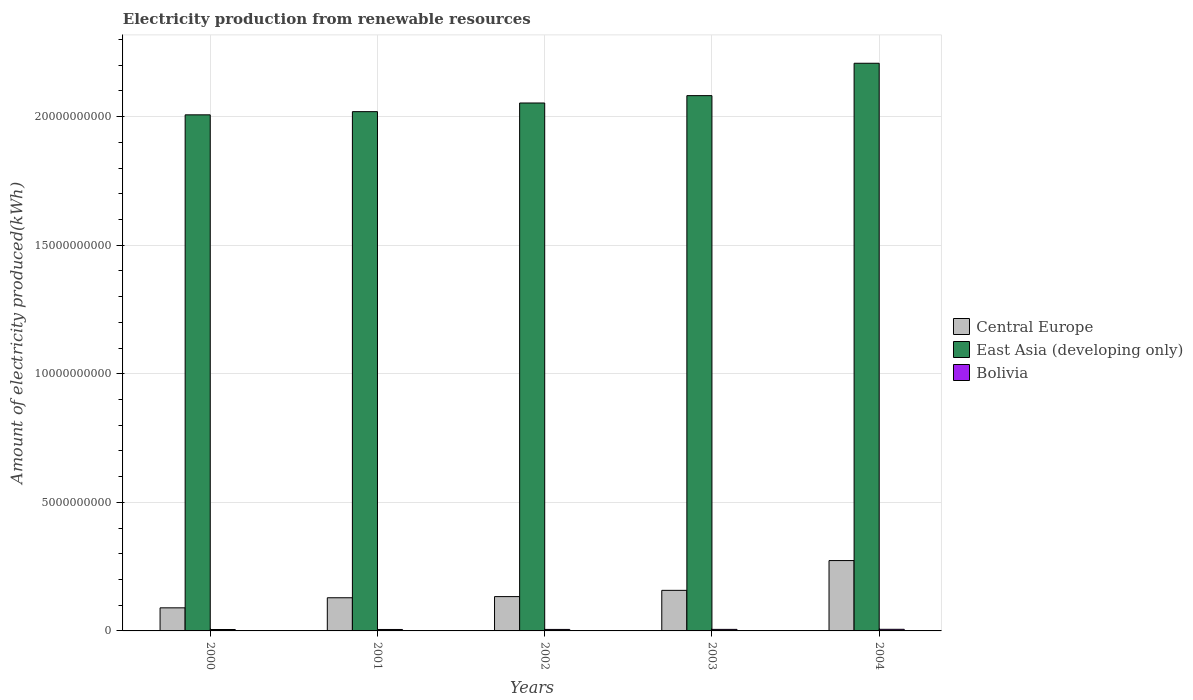What is the amount of electricity produced in Bolivia in 2003?
Make the answer very short. 6.00e+07. Across all years, what is the maximum amount of electricity produced in Bolivia?
Make the answer very short. 6.30e+07. Across all years, what is the minimum amount of electricity produced in Bolivia?
Ensure brevity in your answer.  5.50e+07. What is the total amount of electricity produced in Bolivia in the graph?
Provide a short and direct response. 2.92e+08. What is the difference between the amount of electricity produced in East Asia (developing only) in 2000 and that in 2004?
Offer a very short reply. -2.01e+09. What is the difference between the amount of electricity produced in Central Europe in 2003 and the amount of electricity produced in Bolivia in 2004?
Offer a very short reply. 1.52e+09. What is the average amount of electricity produced in Bolivia per year?
Give a very brief answer. 5.84e+07. In the year 2002, what is the difference between the amount of electricity produced in Central Europe and amount of electricity produced in East Asia (developing only)?
Offer a terse response. -1.92e+1. What is the ratio of the amount of electricity produced in East Asia (developing only) in 2000 to that in 2001?
Give a very brief answer. 0.99. Is the difference between the amount of electricity produced in Central Europe in 2000 and 2001 greater than the difference between the amount of electricity produced in East Asia (developing only) in 2000 and 2001?
Your answer should be very brief. No. What is the difference between the highest and the second highest amount of electricity produced in Bolivia?
Give a very brief answer. 3.00e+06. What is the difference between the highest and the lowest amount of electricity produced in East Asia (developing only)?
Keep it short and to the point. 2.01e+09. In how many years, is the amount of electricity produced in Bolivia greater than the average amount of electricity produced in Bolivia taken over all years?
Provide a succinct answer. 2. What does the 2nd bar from the right in 2003 represents?
Offer a very short reply. East Asia (developing only). Is it the case that in every year, the sum of the amount of electricity produced in Central Europe and amount of electricity produced in Bolivia is greater than the amount of electricity produced in East Asia (developing only)?
Ensure brevity in your answer.  No. Are the values on the major ticks of Y-axis written in scientific E-notation?
Offer a terse response. No. Does the graph contain grids?
Ensure brevity in your answer.  Yes. Where does the legend appear in the graph?
Offer a terse response. Center right. How many legend labels are there?
Your answer should be very brief. 3. How are the legend labels stacked?
Your response must be concise. Vertical. What is the title of the graph?
Your response must be concise. Electricity production from renewable resources. Does "India" appear as one of the legend labels in the graph?
Offer a terse response. No. What is the label or title of the X-axis?
Make the answer very short. Years. What is the label or title of the Y-axis?
Provide a succinct answer. Amount of electricity produced(kWh). What is the Amount of electricity produced(kWh) in Central Europe in 2000?
Your answer should be very brief. 8.98e+08. What is the Amount of electricity produced(kWh) of East Asia (developing only) in 2000?
Your response must be concise. 2.01e+1. What is the Amount of electricity produced(kWh) of Bolivia in 2000?
Make the answer very short. 5.50e+07. What is the Amount of electricity produced(kWh) in Central Europe in 2001?
Your answer should be very brief. 1.29e+09. What is the Amount of electricity produced(kWh) in East Asia (developing only) in 2001?
Make the answer very short. 2.02e+1. What is the Amount of electricity produced(kWh) in Bolivia in 2001?
Your answer should be compact. 5.60e+07. What is the Amount of electricity produced(kWh) of Central Europe in 2002?
Provide a succinct answer. 1.34e+09. What is the Amount of electricity produced(kWh) of East Asia (developing only) in 2002?
Offer a terse response. 2.05e+1. What is the Amount of electricity produced(kWh) of Bolivia in 2002?
Offer a terse response. 5.80e+07. What is the Amount of electricity produced(kWh) of Central Europe in 2003?
Your response must be concise. 1.58e+09. What is the Amount of electricity produced(kWh) of East Asia (developing only) in 2003?
Provide a succinct answer. 2.08e+1. What is the Amount of electricity produced(kWh) in Bolivia in 2003?
Offer a very short reply. 6.00e+07. What is the Amount of electricity produced(kWh) in Central Europe in 2004?
Offer a terse response. 2.74e+09. What is the Amount of electricity produced(kWh) in East Asia (developing only) in 2004?
Make the answer very short. 2.21e+1. What is the Amount of electricity produced(kWh) of Bolivia in 2004?
Offer a very short reply. 6.30e+07. Across all years, what is the maximum Amount of electricity produced(kWh) of Central Europe?
Your response must be concise. 2.74e+09. Across all years, what is the maximum Amount of electricity produced(kWh) in East Asia (developing only)?
Keep it short and to the point. 2.21e+1. Across all years, what is the maximum Amount of electricity produced(kWh) of Bolivia?
Ensure brevity in your answer.  6.30e+07. Across all years, what is the minimum Amount of electricity produced(kWh) of Central Europe?
Keep it short and to the point. 8.98e+08. Across all years, what is the minimum Amount of electricity produced(kWh) of East Asia (developing only)?
Your answer should be compact. 2.01e+1. Across all years, what is the minimum Amount of electricity produced(kWh) of Bolivia?
Provide a short and direct response. 5.50e+07. What is the total Amount of electricity produced(kWh) in Central Europe in the graph?
Offer a very short reply. 7.84e+09. What is the total Amount of electricity produced(kWh) of East Asia (developing only) in the graph?
Your response must be concise. 1.04e+11. What is the total Amount of electricity produced(kWh) in Bolivia in the graph?
Offer a very short reply. 2.92e+08. What is the difference between the Amount of electricity produced(kWh) in Central Europe in 2000 and that in 2001?
Ensure brevity in your answer.  -3.92e+08. What is the difference between the Amount of electricity produced(kWh) in East Asia (developing only) in 2000 and that in 2001?
Your response must be concise. -1.24e+08. What is the difference between the Amount of electricity produced(kWh) of Bolivia in 2000 and that in 2001?
Provide a short and direct response. -1.00e+06. What is the difference between the Amount of electricity produced(kWh) in Central Europe in 2000 and that in 2002?
Provide a succinct answer. -4.37e+08. What is the difference between the Amount of electricity produced(kWh) in East Asia (developing only) in 2000 and that in 2002?
Offer a very short reply. -4.61e+08. What is the difference between the Amount of electricity produced(kWh) in Central Europe in 2000 and that in 2003?
Your answer should be compact. -6.80e+08. What is the difference between the Amount of electricity produced(kWh) of East Asia (developing only) in 2000 and that in 2003?
Provide a short and direct response. -7.47e+08. What is the difference between the Amount of electricity produced(kWh) in Bolivia in 2000 and that in 2003?
Your response must be concise. -5.00e+06. What is the difference between the Amount of electricity produced(kWh) in Central Europe in 2000 and that in 2004?
Make the answer very short. -1.84e+09. What is the difference between the Amount of electricity produced(kWh) in East Asia (developing only) in 2000 and that in 2004?
Offer a terse response. -2.01e+09. What is the difference between the Amount of electricity produced(kWh) in Bolivia in 2000 and that in 2004?
Make the answer very short. -8.00e+06. What is the difference between the Amount of electricity produced(kWh) of Central Europe in 2001 and that in 2002?
Offer a very short reply. -4.50e+07. What is the difference between the Amount of electricity produced(kWh) of East Asia (developing only) in 2001 and that in 2002?
Provide a short and direct response. -3.37e+08. What is the difference between the Amount of electricity produced(kWh) in Bolivia in 2001 and that in 2002?
Your answer should be compact. -2.00e+06. What is the difference between the Amount of electricity produced(kWh) of Central Europe in 2001 and that in 2003?
Your answer should be compact. -2.88e+08. What is the difference between the Amount of electricity produced(kWh) in East Asia (developing only) in 2001 and that in 2003?
Offer a very short reply. -6.23e+08. What is the difference between the Amount of electricity produced(kWh) of Bolivia in 2001 and that in 2003?
Your answer should be very brief. -4.00e+06. What is the difference between the Amount of electricity produced(kWh) of Central Europe in 2001 and that in 2004?
Ensure brevity in your answer.  -1.45e+09. What is the difference between the Amount of electricity produced(kWh) in East Asia (developing only) in 2001 and that in 2004?
Your answer should be compact. -1.88e+09. What is the difference between the Amount of electricity produced(kWh) of Bolivia in 2001 and that in 2004?
Your answer should be very brief. -7.00e+06. What is the difference between the Amount of electricity produced(kWh) of Central Europe in 2002 and that in 2003?
Provide a short and direct response. -2.43e+08. What is the difference between the Amount of electricity produced(kWh) of East Asia (developing only) in 2002 and that in 2003?
Offer a terse response. -2.86e+08. What is the difference between the Amount of electricity produced(kWh) of Central Europe in 2002 and that in 2004?
Offer a very short reply. -1.40e+09. What is the difference between the Amount of electricity produced(kWh) of East Asia (developing only) in 2002 and that in 2004?
Offer a terse response. -1.54e+09. What is the difference between the Amount of electricity produced(kWh) of Bolivia in 2002 and that in 2004?
Offer a very short reply. -5.00e+06. What is the difference between the Amount of electricity produced(kWh) in Central Europe in 2003 and that in 2004?
Your answer should be very brief. -1.16e+09. What is the difference between the Amount of electricity produced(kWh) in East Asia (developing only) in 2003 and that in 2004?
Your answer should be very brief. -1.26e+09. What is the difference between the Amount of electricity produced(kWh) of Central Europe in 2000 and the Amount of electricity produced(kWh) of East Asia (developing only) in 2001?
Give a very brief answer. -1.93e+1. What is the difference between the Amount of electricity produced(kWh) in Central Europe in 2000 and the Amount of electricity produced(kWh) in Bolivia in 2001?
Your answer should be compact. 8.42e+08. What is the difference between the Amount of electricity produced(kWh) of East Asia (developing only) in 2000 and the Amount of electricity produced(kWh) of Bolivia in 2001?
Your response must be concise. 2.00e+1. What is the difference between the Amount of electricity produced(kWh) of Central Europe in 2000 and the Amount of electricity produced(kWh) of East Asia (developing only) in 2002?
Your answer should be compact. -1.96e+1. What is the difference between the Amount of electricity produced(kWh) of Central Europe in 2000 and the Amount of electricity produced(kWh) of Bolivia in 2002?
Ensure brevity in your answer.  8.40e+08. What is the difference between the Amount of electricity produced(kWh) in East Asia (developing only) in 2000 and the Amount of electricity produced(kWh) in Bolivia in 2002?
Provide a succinct answer. 2.00e+1. What is the difference between the Amount of electricity produced(kWh) of Central Europe in 2000 and the Amount of electricity produced(kWh) of East Asia (developing only) in 2003?
Give a very brief answer. -1.99e+1. What is the difference between the Amount of electricity produced(kWh) in Central Europe in 2000 and the Amount of electricity produced(kWh) in Bolivia in 2003?
Give a very brief answer. 8.38e+08. What is the difference between the Amount of electricity produced(kWh) in East Asia (developing only) in 2000 and the Amount of electricity produced(kWh) in Bolivia in 2003?
Make the answer very short. 2.00e+1. What is the difference between the Amount of electricity produced(kWh) in Central Europe in 2000 and the Amount of electricity produced(kWh) in East Asia (developing only) in 2004?
Ensure brevity in your answer.  -2.12e+1. What is the difference between the Amount of electricity produced(kWh) of Central Europe in 2000 and the Amount of electricity produced(kWh) of Bolivia in 2004?
Provide a short and direct response. 8.35e+08. What is the difference between the Amount of electricity produced(kWh) of East Asia (developing only) in 2000 and the Amount of electricity produced(kWh) of Bolivia in 2004?
Provide a succinct answer. 2.00e+1. What is the difference between the Amount of electricity produced(kWh) of Central Europe in 2001 and the Amount of electricity produced(kWh) of East Asia (developing only) in 2002?
Your answer should be compact. -1.92e+1. What is the difference between the Amount of electricity produced(kWh) of Central Europe in 2001 and the Amount of electricity produced(kWh) of Bolivia in 2002?
Make the answer very short. 1.23e+09. What is the difference between the Amount of electricity produced(kWh) of East Asia (developing only) in 2001 and the Amount of electricity produced(kWh) of Bolivia in 2002?
Your answer should be very brief. 2.01e+1. What is the difference between the Amount of electricity produced(kWh) in Central Europe in 2001 and the Amount of electricity produced(kWh) in East Asia (developing only) in 2003?
Give a very brief answer. -1.95e+1. What is the difference between the Amount of electricity produced(kWh) of Central Europe in 2001 and the Amount of electricity produced(kWh) of Bolivia in 2003?
Provide a succinct answer. 1.23e+09. What is the difference between the Amount of electricity produced(kWh) of East Asia (developing only) in 2001 and the Amount of electricity produced(kWh) of Bolivia in 2003?
Offer a terse response. 2.01e+1. What is the difference between the Amount of electricity produced(kWh) of Central Europe in 2001 and the Amount of electricity produced(kWh) of East Asia (developing only) in 2004?
Offer a terse response. -2.08e+1. What is the difference between the Amount of electricity produced(kWh) in Central Europe in 2001 and the Amount of electricity produced(kWh) in Bolivia in 2004?
Make the answer very short. 1.23e+09. What is the difference between the Amount of electricity produced(kWh) of East Asia (developing only) in 2001 and the Amount of electricity produced(kWh) of Bolivia in 2004?
Provide a short and direct response. 2.01e+1. What is the difference between the Amount of electricity produced(kWh) of Central Europe in 2002 and the Amount of electricity produced(kWh) of East Asia (developing only) in 2003?
Your answer should be compact. -1.95e+1. What is the difference between the Amount of electricity produced(kWh) of Central Europe in 2002 and the Amount of electricity produced(kWh) of Bolivia in 2003?
Make the answer very short. 1.28e+09. What is the difference between the Amount of electricity produced(kWh) in East Asia (developing only) in 2002 and the Amount of electricity produced(kWh) in Bolivia in 2003?
Ensure brevity in your answer.  2.05e+1. What is the difference between the Amount of electricity produced(kWh) of Central Europe in 2002 and the Amount of electricity produced(kWh) of East Asia (developing only) in 2004?
Your answer should be very brief. -2.07e+1. What is the difference between the Amount of electricity produced(kWh) in Central Europe in 2002 and the Amount of electricity produced(kWh) in Bolivia in 2004?
Make the answer very short. 1.27e+09. What is the difference between the Amount of electricity produced(kWh) in East Asia (developing only) in 2002 and the Amount of electricity produced(kWh) in Bolivia in 2004?
Your answer should be very brief. 2.05e+1. What is the difference between the Amount of electricity produced(kWh) in Central Europe in 2003 and the Amount of electricity produced(kWh) in East Asia (developing only) in 2004?
Make the answer very short. -2.05e+1. What is the difference between the Amount of electricity produced(kWh) in Central Europe in 2003 and the Amount of electricity produced(kWh) in Bolivia in 2004?
Provide a short and direct response. 1.52e+09. What is the difference between the Amount of electricity produced(kWh) in East Asia (developing only) in 2003 and the Amount of electricity produced(kWh) in Bolivia in 2004?
Give a very brief answer. 2.08e+1. What is the average Amount of electricity produced(kWh) in Central Europe per year?
Keep it short and to the point. 1.57e+09. What is the average Amount of electricity produced(kWh) of East Asia (developing only) per year?
Offer a terse response. 2.07e+1. What is the average Amount of electricity produced(kWh) in Bolivia per year?
Your response must be concise. 5.84e+07. In the year 2000, what is the difference between the Amount of electricity produced(kWh) in Central Europe and Amount of electricity produced(kWh) in East Asia (developing only)?
Give a very brief answer. -1.92e+1. In the year 2000, what is the difference between the Amount of electricity produced(kWh) of Central Europe and Amount of electricity produced(kWh) of Bolivia?
Your answer should be very brief. 8.43e+08. In the year 2000, what is the difference between the Amount of electricity produced(kWh) in East Asia (developing only) and Amount of electricity produced(kWh) in Bolivia?
Provide a short and direct response. 2.00e+1. In the year 2001, what is the difference between the Amount of electricity produced(kWh) in Central Europe and Amount of electricity produced(kWh) in East Asia (developing only)?
Your response must be concise. -1.89e+1. In the year 2001, what is the difference between the Amount of electricity produced(kWh) in Central Europe and Amount of electricity produced(kWh) in Bolivia?
Keep it short and to the point. 1.23e+09. In the year 2001, what is the difference between the Amount of electricity produced(kWh) in East Asia (developing only) and Amount of electricity produced(kWh) in Bolivia?
Offer a terse response. 2.01e+1. In the year 2002, what is the difference between the Amount of electricity produced(kWh) of Central Europe and Amount of electricity produced(kWh) of East Asia (developing only)?
Your answer should be compact. -1.92e+1. In the year 2002, what is the difference between the Amount of electricity produced(kWh) in Central Europe and Amount of electricity produced(kWh) in Bolivia?
Your answer should be compact. 1.28e+09. In the year 2002, what is the difference between the Amount of electricity produced(kWh) of East Asia (developing only) and Amount of electricity produced(kWh) of Bolivia?
Make the answer very short. 2.05e+1. In the year 2003, what is the difference between the Amount of electricity produced(kWh) in Central Europe and Amount of electricity produced(kWh) in East Asia (developing only)?
Provide a succinct answer. -1.92e+1. In the year 2003, what is the difference between the Amount of electricity produced(kWh) of Central Europe and Amount of electricity produced(kWh) of Bolivia?
Ensure brevity in your answer.  1.52e+09. In the year 2003, what is the difference between the Amount of electricity produced(kWh) in East Asia (developing only) and Amount of electricity produced(kWh) in Bolivia?
Make the answer very short. 2.08e+1. In the year 2004, what is the difference between the Amount of electricity produced(kWh) of Central Europe and Amount of electricity produced(kWh) of East Asia (developing only)?
Your answer should be very brief. -1.93e+1. In the year 2004, what is the difference between the Amount of electricity produced(kWh) of Central Europe and Amount of electricity produced(kWh) of Bolivia?
Ensure brevity in your answer.  2.67e+09. In the year 2004, what is the difference between the Amount of electricity produced(kWh) of East Asia (developing only) and Amount of electricity produced(kWh) of Bolivia?
Your response must be concise. 2.20e+1. What is the ratio of the Amount of electricity produced(kWh) of Central Europe in 2000 to that in 2001?
Provide a succinct answer. 0.7. What is the ratio of the Amount of electricity produced(kWh) of Bolivia in 2000 to that in 2001?
Ensure brevity in your answer.  0.98. What is the ratio of the Amount of electricity produced(kWh) of Central Europe in 2000 to that in 2002?
Your response must be concise. 0.67. What is the ratio of the Amount of electricity produced(kWh) in East Asia (developing only) in 2000 to that in 2002?
Give a very brief answer. 0.98. What is the ratio of the Amount of electricity produced(kWh) in Bolivia in 2000 to that in 2002?
Give a very brief answer. 0.95. What is the ratio of the Amount of electricity produced(kWh) of Central Europe in 2000 to that in 2003?
Give a very brief answer. 0.57. What is the ratio of the Amount of electricity produced(kWh) in East Asia (developing only) in 2000 to that in 2003?
Your answer should be very brief. 0.96. What is the ratio of the Amount of electricity produced(kWh) of Bolivia in 2000 to that in 2003?
Your answer should be compact. 0.92. What is the ratio of the Amount of electricity produced(kWh) in Central Europe in 2000 to that in 2004?
Your response must be concise. 0.33. What is the ratio of the Amount of electricity produced(kWh) in East Asia (developing only) in 2000 to that in 2004?
Keep it short and to the point. 0.91. What is the ratio of the Amount of electricity produced(kWh) in Bolivia in 2000 to that in 2004?
Offer a very short reply. 0.87. What is the ratio of the Amount of electricity produced(kWh) of Central Europe in 2001 to that in 2002?
Your answer should be very brief. 0.97. What is the ratio of the Amount of electricity produced(kWh) of East Asia (developing only) in 2001 to that in 2002?
Provide a short and direct response. 0.98. What is the ratio of the Amount of electricity produced(kWh) in Bolivia in 2001 to that in 2002?
Give a very brief answer. 0.97. What is the ratio of the Amount of electricity produced(kWh) of Central Europe in 2001 to that in 2003?
Ensure brevity in your answer.  0.82. What is the ratio of the Amount of electricity produced(kWh) in East Asia (developing only) in 2001 to that in 2003?
Offer a terse response. 0.97. What is the ratio of the Amount of electricity produced(kWh) of Bolivia in 2001 to that in 2003?
Keep it short and to the point. 0.93. What is the ratio of the Amount of electricity produced(kWh) in Central Europe in 2001 to that in 2004?
Your response must be concise. 0.47. What is the ratio of the Amount of electricity produced(kWh) of East Asia (developing only) in 2001 to that in 2004?
Offer a terse response. 0.91. What is the ratio of the Amount of electricity produced(kWh) in Bolivia in 2001 to that in 2004?
Provide a short and direct response. 0.89. What is the ratio of the Amount of electricity produced(kWh) of Central Europe in 2002 to that in 2003?
Offer a very short reply. 0.85. What is the ratio of the Amount of electricity produced(kWh) in East Asia (developing only) in 2002 to that in 2003?
Offer a terse response. 0.99. What is the ratio of the Amount of electricity produced(kWh) in Bolivia in 2002 to that in 2003?
Your response must be concise. 0.97. What is the ratio of the Amount of electricity produced(kWh) in Central Europe in 2002 to that in 2004?
Ensure brevity in your answer.  0.49. What is the ratio of the Amount of electricity produced(kWh) of Bolivia in 2002 to that in 2004?
Provide a short and direct response. 0.92. What is the ratio of the Amount of electricity produced(kWh) in Central Europe in 2003 to that in 2004?
Give a very brief answer. 0.58. What is the ratio of the Amount of electricity produced(kWh) of East Asia (developing only) in 2003 to that in 2004?
Your answer should be very brief. 0.94. What is the difference between the highest and the second highest Amount of electricity produced(kWh) of Central Europe?
Your answer should be very brief. 1.16e+09. What is the difference between the highest and the second highest Amount of electricity produced(kWh) in East Asia (developing only)?
Keep it short and to the point. 1.26e+09. What is the difference between the highest and the second highest Amount of electricity produced(kWh) of Bolivia?
Ensure brevity in your answer.  3.00e+06. What is the difference between the highest and the lowest Amount of electricity produced(kWh) of Central Europe?
Give a very brief answer. 1.84e+09. What is the difference between the highest and the lowest Amount of electricity produced(kWh) in East Asia (developing only)?
Keep it short and to the point. 2.01e+09. 